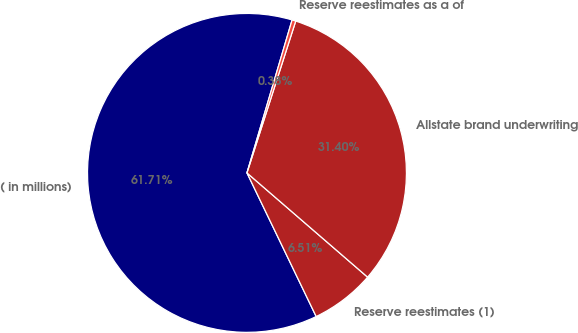<chart> <loc_0><loc_0><loc_500><loc_500><pie_chart><fcel>( in millions)<fcel>Reserve reestimates (1)<fcel>Allstate brand underwriting<fcel>Reserve reestimates as a of<nl><fcel>61.72%<fcel>6.51%<fcel>31.4%<fcel>0.38%<nl></chart> 